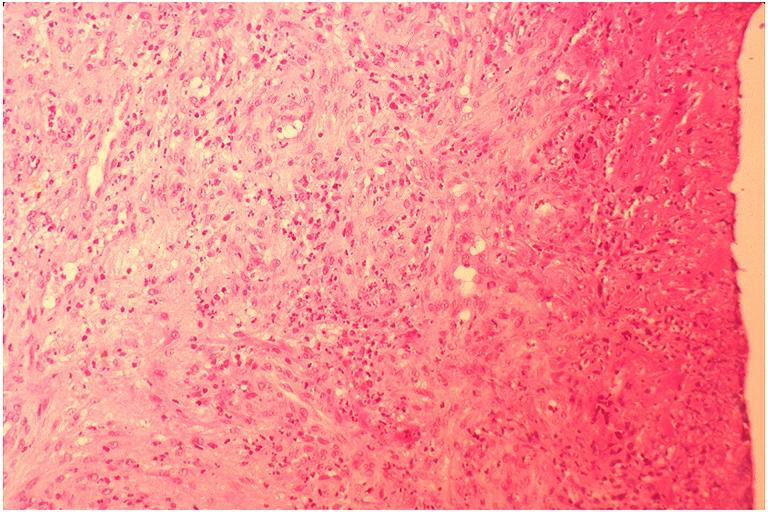does this image show pyogenic granuloma?
Answer the question using a single word or phrase. Yes 